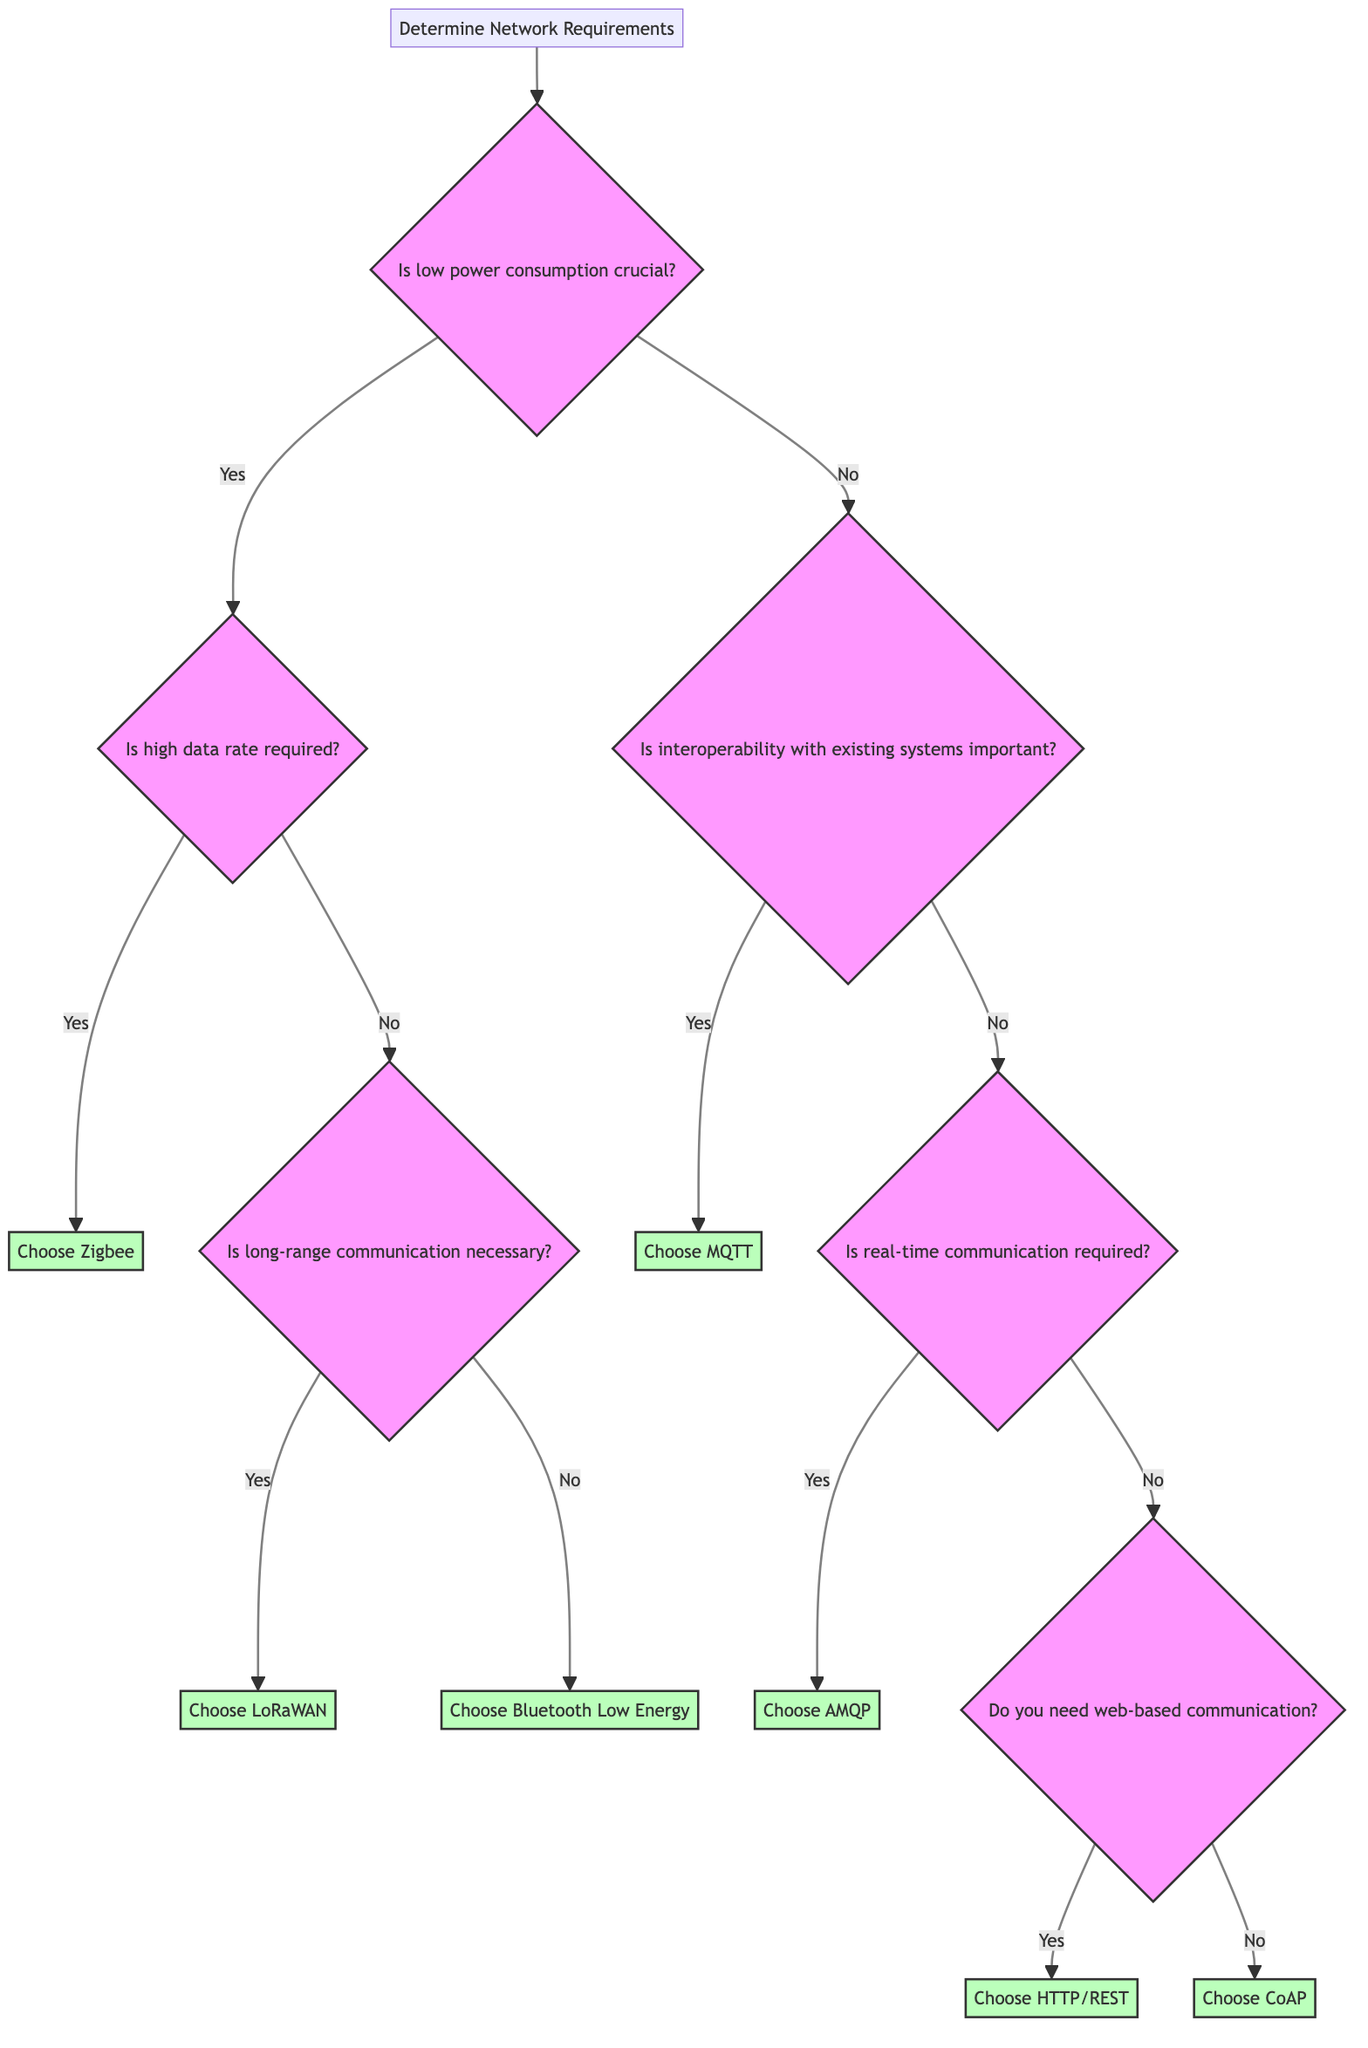What is the starting point of the decision tree? The decision tree begins with the node labeled "Determine Network Requirements," indicating that this is the first step in the decision-making process.
Answer: Determine Network Requirements How many main questions are present in the diagram? There are a total of six main questions represented in the diagram that guide the user through the decision-making process.
Answer: Six What is the result when low power consumption is not crucial and interoperability is important? Following the path where low power consumption is not crucial leads to the question about interoperability. If interoperability is important, the result is "Choose MQTT."
Answer: Choose MQTT What protocol is chosen if long-range communication is necessary? If the user indicates that long-range communication is necessary after asking about high data rate requirements, the protocol chosen is "Choose LoRaWAN."
Answer: Choose LoRaWAN Which communication protocol is selected if real-time communication is not required and web-based communication is needed? In this scenario, the path leads to the question regarding web-based communication. If the answer is yes, the protocol chosen will be "Choose HTTP/REST."
Answer: Choose HTTP/REST What is the final protocol choice if low power consumption is critical and both high data rate and long-range communication are not required? Starting from low power consumption being critical, we check for high data rate (not required) and proceed to long-range communication, which also is not necessary, leading to the choice of "Choose Bluetooth Low Energy."
Answer: Choose Bluetooth Low Energy 